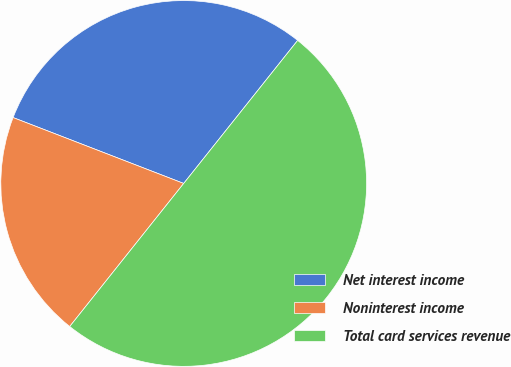Convert chart to OTSL. <chart><loc_0><loc_0><loc_500><loc_500><pie_chart><fcel>Net interest income<fcel>Noninterest income<fcel>Total card services revenue<nl><fcel>29.84%<fcel>20.16%<fcel>50.0%<nl></chart> 